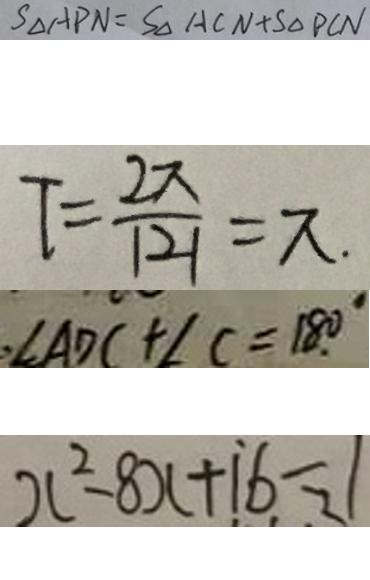Convert formula to latex. <formula><loc_0><loc_0><loc_500><loc_500>S _ { \Delta } A P N = S _ { \Delta } A C N + S _ { \Delta } P C N 
 T = \frac { 2 \pi } { \vert 2 \vert } = \pi . 
 \angle A D C + \angle C = 1 8 0 ^ { \circ } 
 x ^ { 2 } - 8 x + 1 6 = 1</formula> 